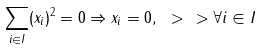<formula> <loc_0><loc_0><loc_500><loc_500>\sum _ { i \in I } ( x _ { i } ) ^ { 2 } = 0 \Rightarrow x _ { i } = 0 , \ > \ > \forall i \in I</formula> 